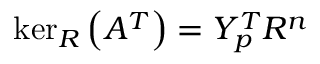<formula> <loc_0><loc_0><loc_500><loc_500>\ker _ { R } \left ( A ^ { T } \right ) = Y _ { p } ^ { T } R ^ { n }</formula> 